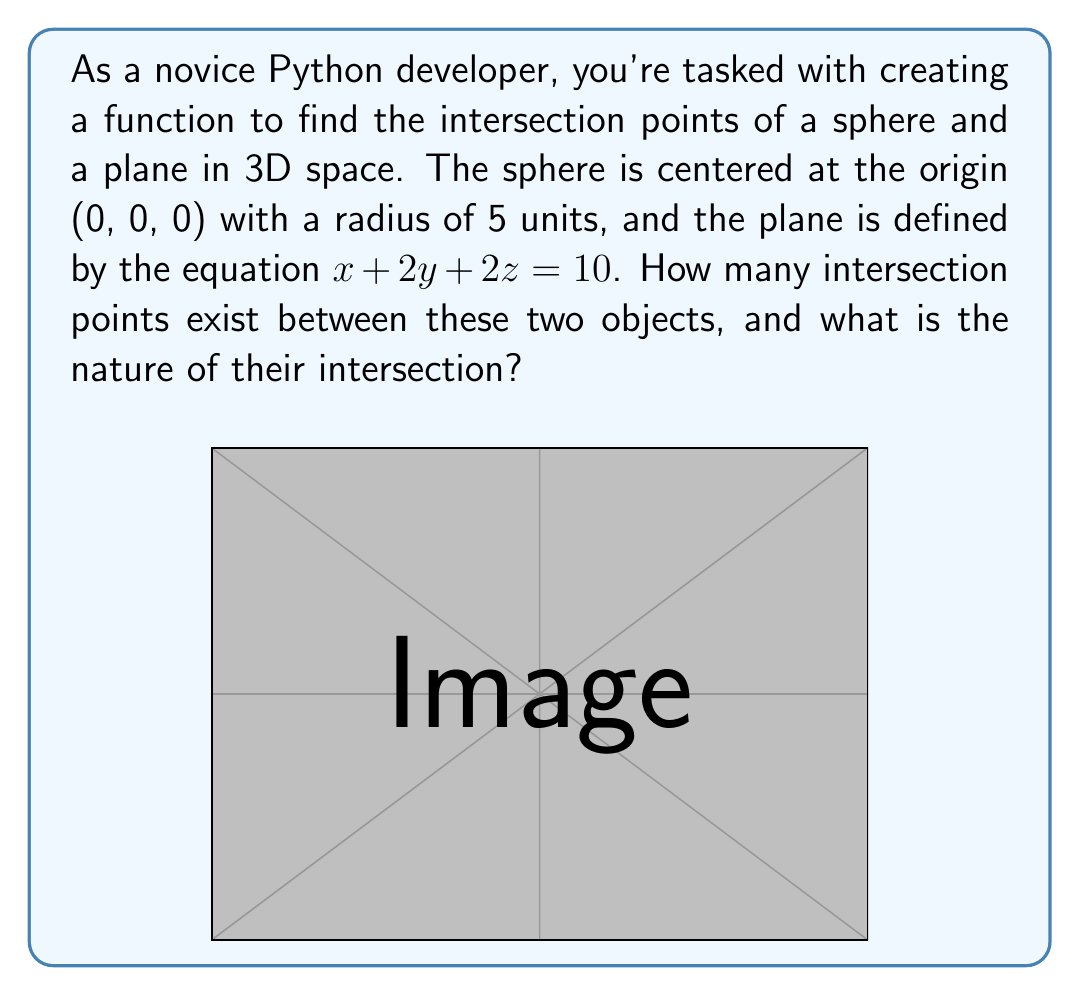Can you answer this question? To solve this problem programmatically, we need to understand the mathematical relationship between the sphere and the plane. Let's approach this step-by-step:

1) The equation of the sphere centered at the origin with radius 5 is:
   
   $$x^2 + y^2 + z^2 = 25$$

2) The equation of the plane is:
   
   $$x + 2y + 2z = 10$$

3) To find the intersection, we need to solve these equations simultaneously. In a Python program, you would substitute the plane equation into the sphere equation:

   Let $x = 10 - 2y - 2z$ (from the plane equation)
   
   $$(10 - 2y - 2z)^2 + y^2 + z^2 = 25$$

4) Expanding this:
   
   $$100 - 40y - 40z + 4y^2 + 8yz + 4z^2 + y^2 + z^2 = 25$$
   
   $$5y^2 + 5z^2 + 8yz - 40y - 40z + 75 = 0$$

5) This is the equation of a conic section in the y-z plane. The nature of this conic section determines the intersection:

   - If it's an ellipse, the intersection is a circle
   - If it's a point, the plane is tangent to the sphere
   - If it's imaginary, there's no intersection

6) To determine the nature, we need to analyze the discriminant of this equation. However, for this specific case, we can observe that the plane intersects the sphere in more than one point, forming a circle.

7) The center of this circle can be found by solving the plane equation with the sphere's center (0,0,0):
   
   $$0 + 2(0) + 2(0) = 10$$
   
   This is not true, so the center of the sphere is not on the plane, confirming a circular intersection.
Answer: The sphere and the plane intersect in infinitely many points, forming a circle. This circle represents the boundary of a circular "slice" of the sphere cut by the plane. 